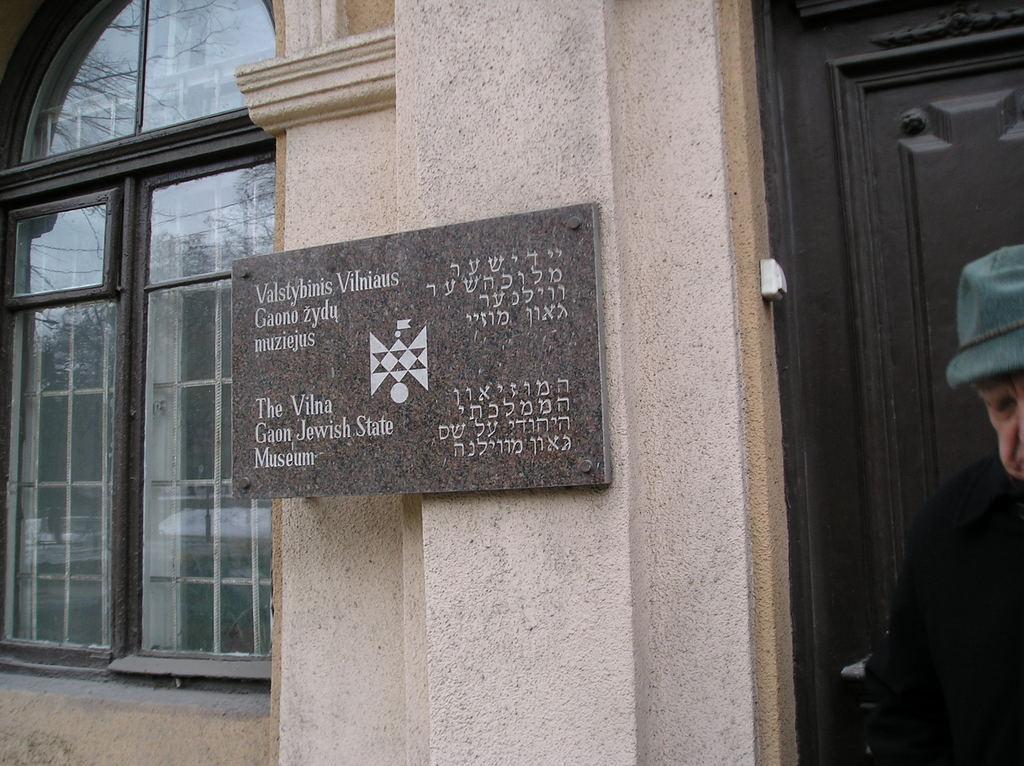Describe this image in one or two sentences. On the right side of the image there is a man. In the background there is a building and we can see a board placed on the wall. We can see a door and a window. 